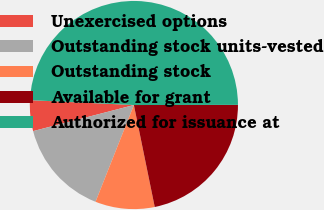Convert chart to OTSL. <chart><loc_0><loc_0><loc_500><loc_500><pie_chart><fcel>Unexercised options<fcel>Outstanding stock units-vested<fcel>Outstanding stock<fcel>Available for grant<fcel>Authorized for issuance at<nl><fcel>4.78%<fcel>14.96%<fcel>9.22%<fcel>21.81%<fcel>49.23%<nl></chart> 